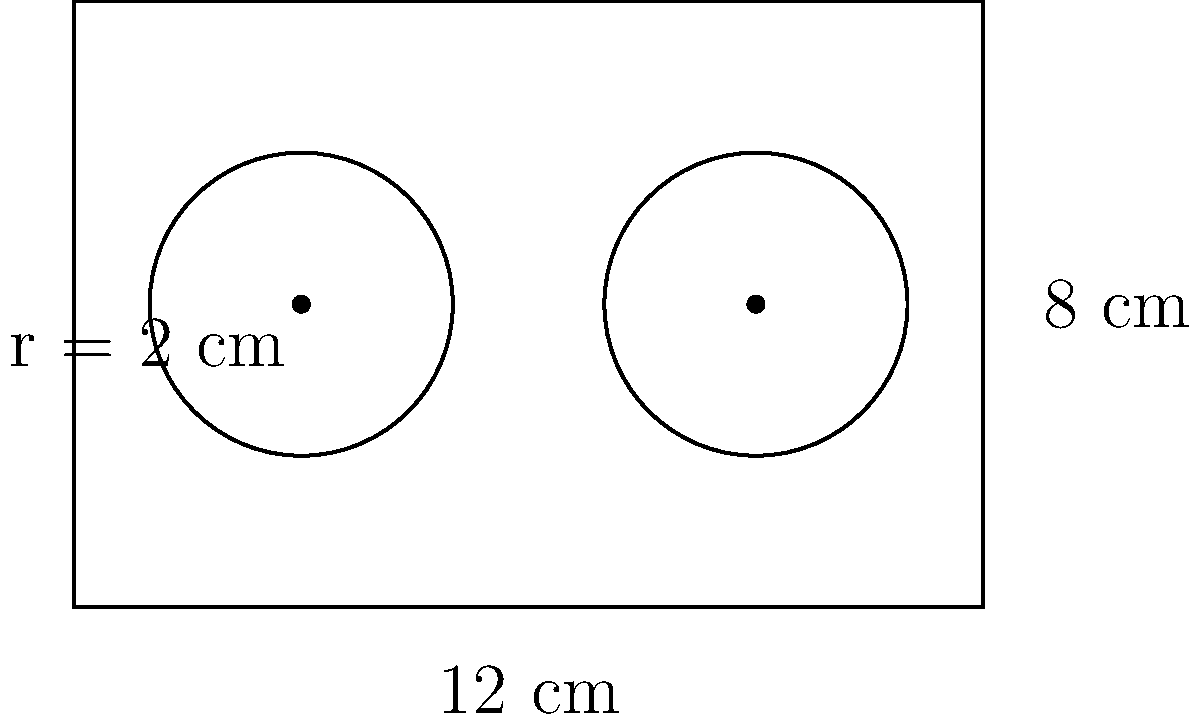You're setting up your DJ turntables for a hip-hop show in Chicago. Your setup includes a rectangular base that's 12 cm long and 8 cm wide, with two circular turntables, each having a radius of 2 cm. What's the total perimeter of your DJ setup, including the rectangular base and both turntables? Round your answer to the nearest centimeter. Let's break this down step-by-step:

1) First, calculate the perimeter of the rectangular base:
   Perimeter of rectangle = 2(length + width)
   $P_{rectangle} = 2(12 + 8) = 2(20) = 40$ cm

2) Now, calculate the circumference of one turntable:
   Circumference of a circle = $2\pi r$
   $C_{turntable} = 2\pi(2) = 4\pi$ cm

3) Since there are two turntables, multiply the circumference by 2:
   $C_{total} = 2(4\pi) = 8\pi$ cm

4) Add the perimeter of the rectangle and the circumferences of both turntables:
   Total perimeter = $P_{rectangle} + C_{total}$
   $= 40 + 8\pi$ cm
   $\approx 40 + 25.13$ cm
   $\approx 65.13$ cm

5) Rounding to the nearest centimeter:
   65.13 cm ≈ 65 cm
Answer: 65 cm 